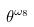<formula> <loc_0><loc_0><loc_500><loc_500>\theta ^ { \omega _ { 8 } }</formula> 